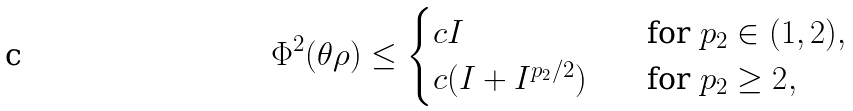<formula> <loc_0><loc_0><loc_500><loc_500>\Phi ^ { 2 } ( \theta \rho ) \leq \begin{cases} c I & \quad \text {for $p_{2}\in(1,2)$} , \\ c ( I + I ^ { p _ { 2 } / 2 } ) & \quad \text {for $p_{2} \geq 2$} , \end{cases}</formula> 